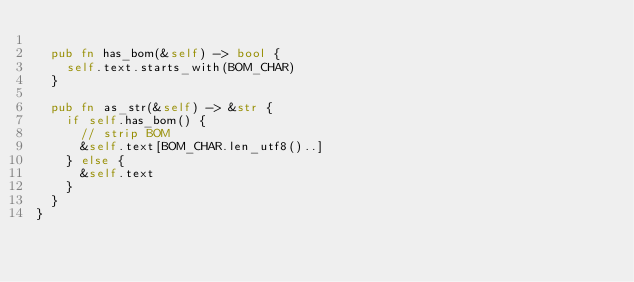Convert code to text. <code><loc_0><loc_0><loc_500><loc_500><_Rust_>
  pub fn has_bom(&self) -> bool {
    self.text.starts_with(BOM_CHAR)
  }

  pub fn as_str(&self) -> &str {
    if self.has_bom() {
      // strip BOM
      &self.text[BOM_CHAR.len_utf8()..]
    } else {
      &self.text
    }
  }
}
</code> 